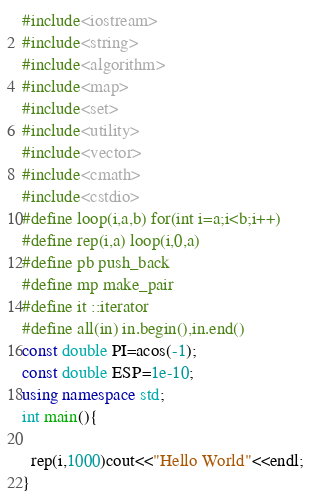Convert code to text. <code><loc_0><loc_0><loc_500><loc_500><_C++_>#include<iostream>
#include<string>
#include<algorithm>
#include<map>
#include<set>
#include<utility>
#include<vector>
#include<cmath>
#include<cstdio>
#define loop(i,a,b) for(int i=a;i<b;i++) 
#define rep(i,a) loop(i,0,a)
#define pb push_back
#define mp make_pair
#define it ::iterator
#define all(in) in.begin(),in.end()
const double PI=acos(-1);
const double ESP=1e-10;
using namespace std;
int main(){

  rep(i,1000)cout<<"Hello World"<<endl;
}</code> 